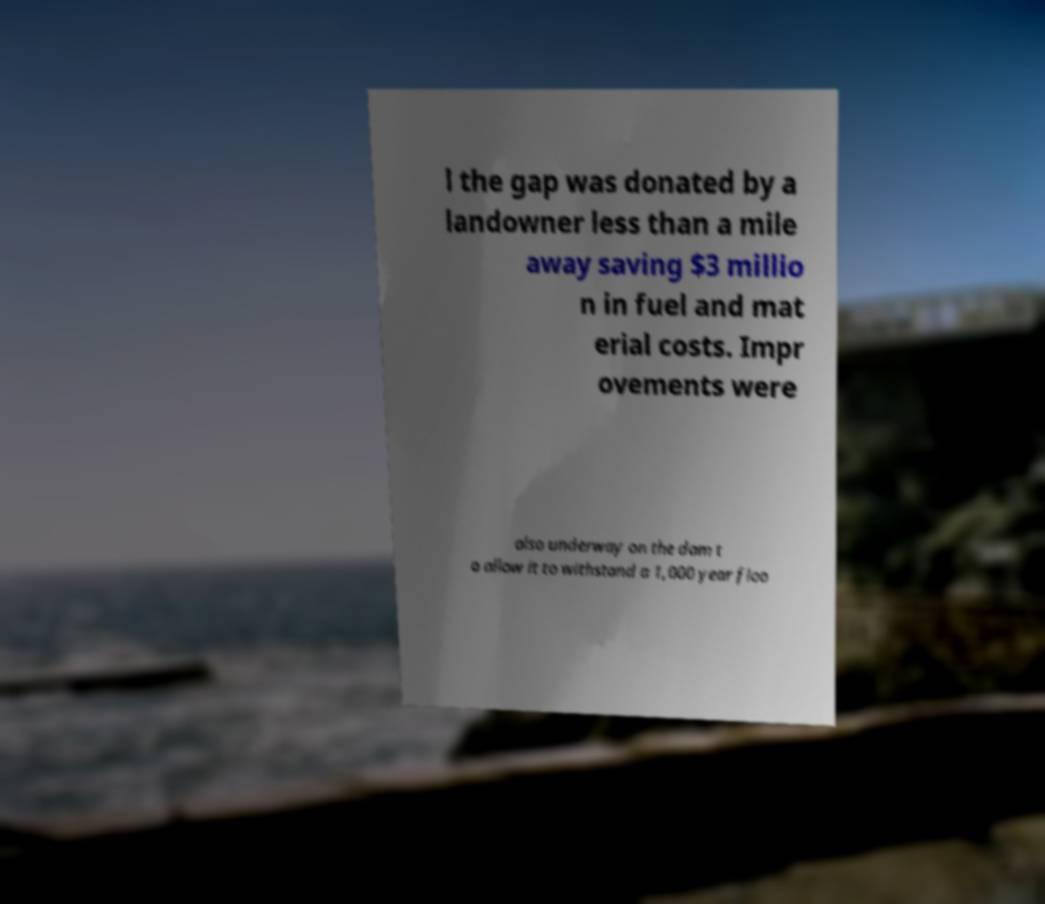For documentation purposes, I need the text within this image transcribed. Could you provide that? l the gap was donated by a landowner less than a mile away saving $3 millio n in fuel and mat erial costs. Impr ovements were also underway on the dam t o allow it to withstand a 1,000 year floo 